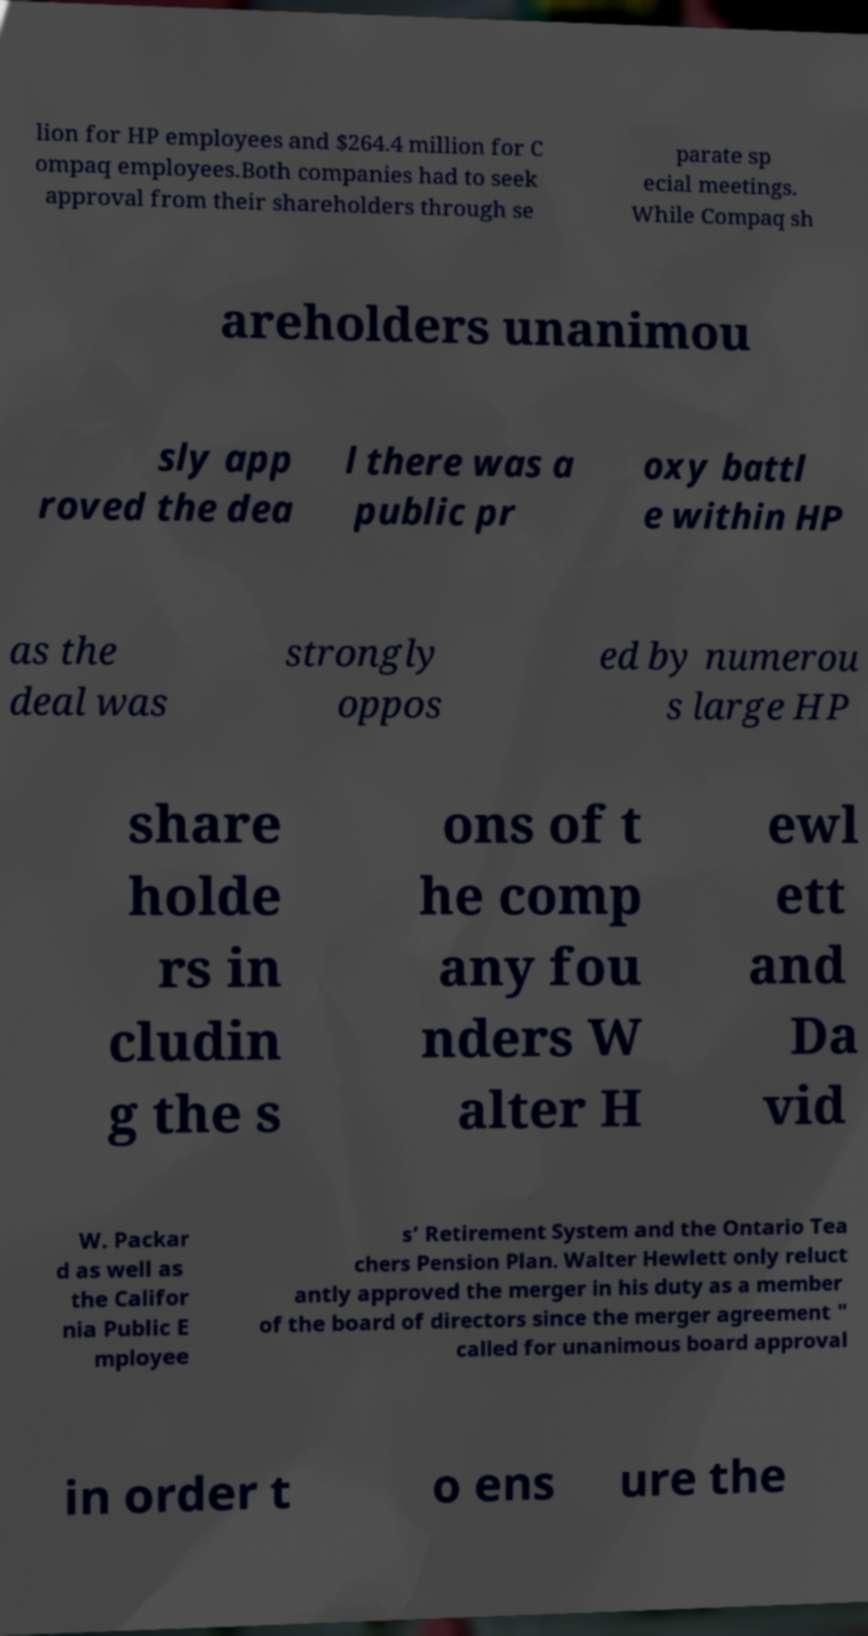Please read and relay the text visible in this image. What does it say? lion for HP employees and $264.4 million for C ompaq employees.Both companies had to seek approval from their shareholders through se parate sp ecial meetings. While Compaq sh areholders unanimou sly app roved the dea l there was a public pr oxy battl e within HP as the deal was strongly oppos ed by numerou s large HP share holde rs in cludin g the s ons of t he comp any fou nders W alter H ewl ett and Da vid W. Packar d as well as the Califor nia Public E mployee s’ Retirement System and the Ontario Tea chers Pension Plan. Walter Hewlett only reluct antly approved the merger in his duty as a member of the board of directors since the merger agreement " called for unanimous board approval in order t o ens ure the 